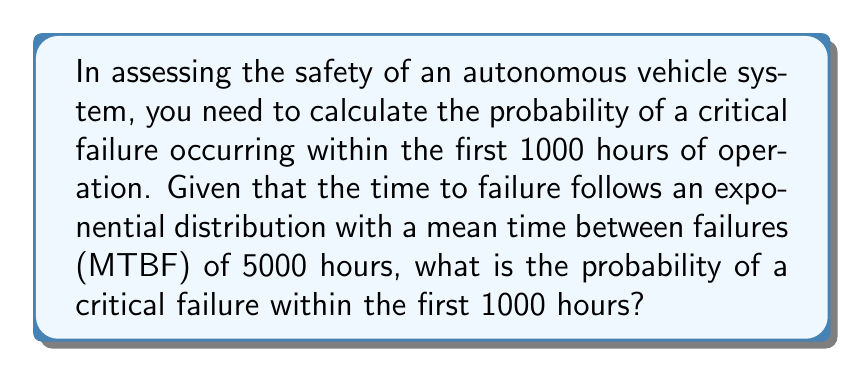What is the answer to this math problem? To solve this problem, we'll use the exponential distribution model, which is commonly used to assess the reliability of systems over time.

Given:
- Mean Time Between Failures (MTBF) = 5000 hours
- Time period of interest (t) = 1000 hours

Step 1: Determine the rate parameter (λ)
The rate parameter λ is the inverse of the MTBF:
$$λ = \frac{1}{\text{MTBF}} = \frac{1}{5000} = 0.0002 \text{ per hour}$$

Step 2: Use the cumulative distribution function (CDF) of the exponential distribution
The CDF gives the probability that a failure occurs within time t:
$$P(T ≤ t) = 1 - e^{-λt}$$

Step 3: Substitute the values into the CDF formula
$$P(T ≤ 1000) = 1 - e^{-0.0002 * 1000}$$

Step 4: Calculate the result
$$P(T ≤ 1000) = 1 - e^{-0.2} = 1 - 0.8187 = 0.1813$$

Step 5: Convert to percentage
0.1813 * 100 = 18.13%
Answer: 18.13% 